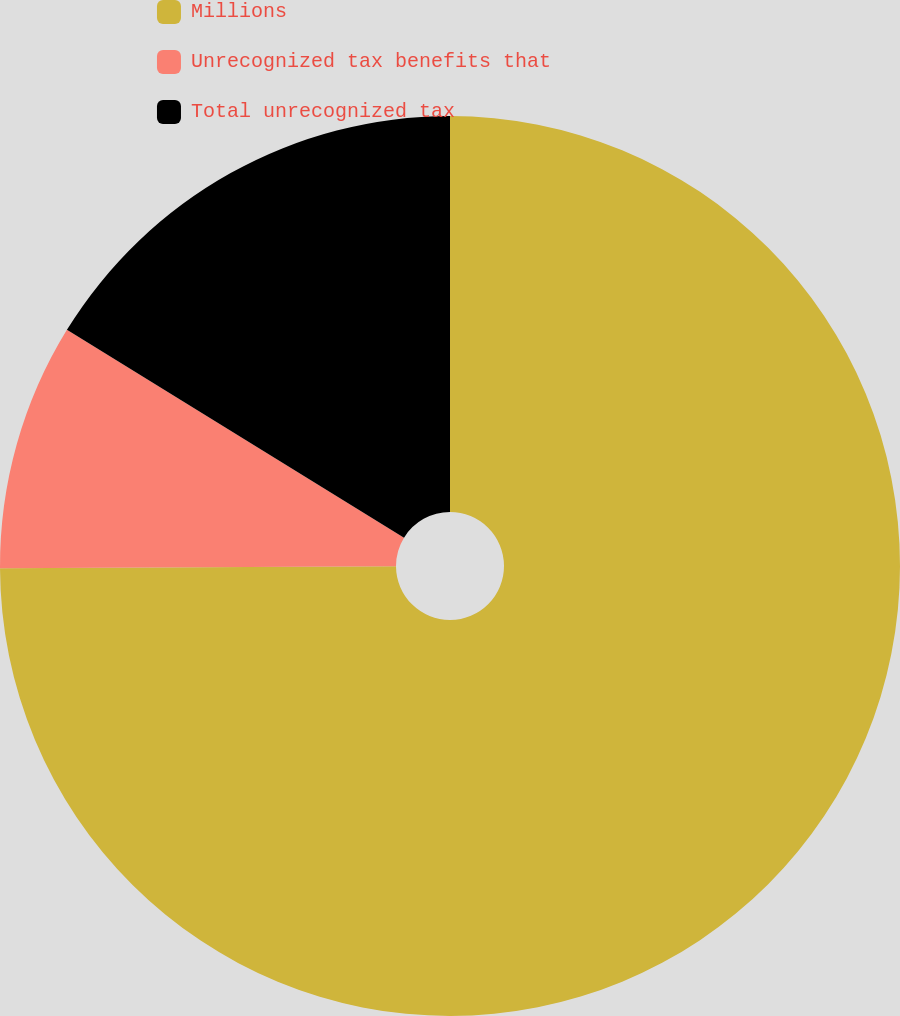Convert chart. <chart><loc_0><loc_0><loc_500><loc_500><pie_chart><fcel>Millions<fcel>Unrecognized tax benefits that<fcel>Total unrecognized tax<nl><fcel>74.93%<fcel>8.87%<fcel>16.21%<nl></chart> 